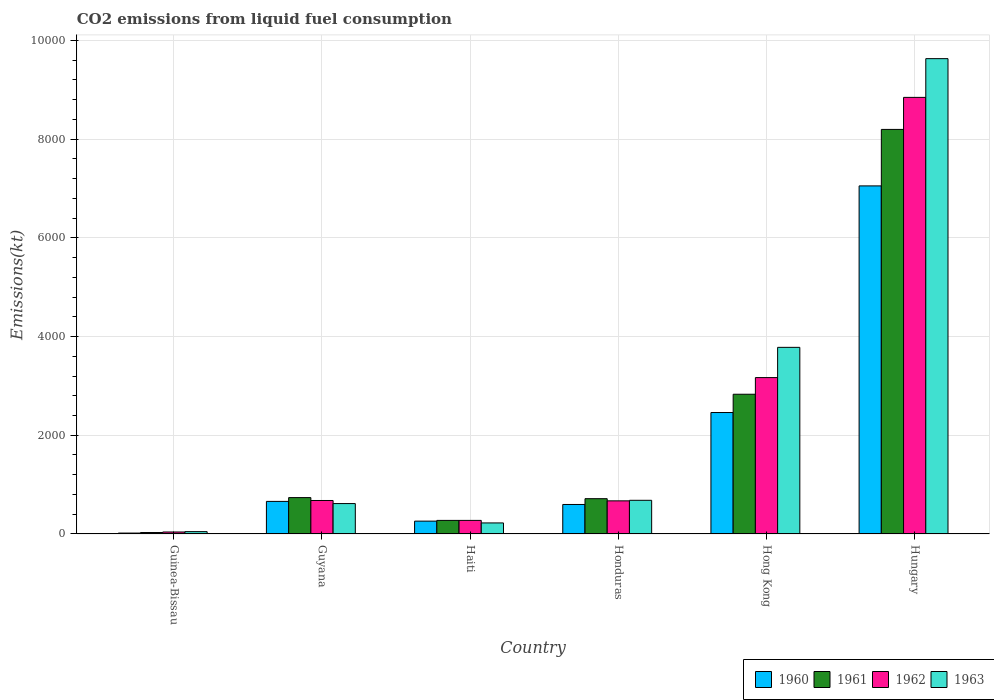How many different coloured bars are there?
Keep it short and to the point. 4. What is the label of the 5th group of bars from the left?
Give a very brief answer. Hong Kong. What is the amount of CO2 emitted in 1960 in Hungary?
Your answer should be very brief. 7051.64. Across all countries, what is the maximum amount of CO2 emitted in 1963?
Ensure brevity in your answer.  9629.54. Across all countries, what is the minimum amount of CO2 emitted in 1960?
Ensure brevity in your answer.  18.34. In which country was the amount of CO2 emitted in 1961 maximum?
Make the answer very short. Hungary. In which country was the amount of CO2 emitted in 1963 minimum?
Make the answer very short. Guinea-Bissau. What is the total amount of CO2 emitted in 1961 in the graph?
Your answer should be very brief. 1.28e+04. What is the difference between the amount of CO2 emitted in 1960 in Haiti and that in Hong Kong?
Ensure brevity in your answer.  -2200.2. What is the difference between the amount of CO2 emitted in 1962 in Haiti and the amount of CO2 emitted in 1963 in Guyana?
Your answer should be compact. -341.03. What is the average amount of CO2 emitted in 1962 per country?
Make the answer very short. 2279.65. What is the difference between the amount of CO2 emitted of/in 1963 and amount of CO2 emitted of/in 1962 in Guyana?
Your response must be concise. -62.34. What is the ratio of the amount of CO2 emitted in 1960 in Guyana to that in Honduras?
Your response must be concise. 1.1. Is the amount of CO2 emitted in 1961 in Guinea-Bissau less than that in Haiti?
Provide a short and direct response. Yes. Is the difference between the amount of CO2 emitted in 1963 in Guinea-Bissau and Hong Kong greater than the difference between the amount of CO2 emitted in 1962 in Guinea-Bissau and Hong Kong?
Make the answer very short. No. What is the difference between the highest and the second highest amount of CO2 emitted in 1962?
Your response must be concise. -5676.52. What is the difference between the highest and the lowest amount of CO2 emitted in 1961?
Keep it short and to the point. 8166.41. Is the sum of the amount of CO2 emitted in 1963 in Guyana and Hungary greater than the maximum amount of CO2 emitted in 1962 across all countries?
Give a very brief answer. Yes. What does the 4th bar from the left in Hungary represents?
Ensure brevity in your answer.  1963. What does the 3rd bar from the right in Guinea-Bissau represents?
Your answer should be very brief. 1961. Is it the case that in every country, the sum of the amount of CO2 emitted in 1963 and amount of CO2 emitted in 1962 is greater than the amount of CO2 emitted in 1960?
Offer a terse response. Yes. How many bars are there?
Make the answer very short. 24. Are all the bars in the graph horizontal?
Offer a very short reply. No. What is the difference between two consecutive major ticks on the Y-axis?
Provide a short and direct response. 2000. What is the title of the graph?
Provide a short and direct response. CO2 emissions from liquid fuel consumption. What is the label or title of the Y-axis?
Provide a succinct answer. Emissions(kt). What is the Emissions(kt) of 1960 in Guinea-Bissau?
Provide a short and direct response. 18.34. What is the Emissions(kt) in 1961 in Guinea-Bissau?
Ensure brevity in your answer.  29.34. What is the Emissions(kt) in 1962 in Guinea-Bissau?
Provide a succinct answer. 40.34. What is the Emissions(kt) of 1963 in Guinea-Bissau?
Offer a very short reply. 47.67. What is the Emissions(kt) in 1960 in Guyana?
Your response must be concise. 660.06. What is the Emissions(kt) in 1961 in Guyana?
Your answer should be very brief. 737.07. What is the Emissions(kt) in 1962 in Guyana?
Your answer should be very brief. 678.39. What is the Emissions(kt) of 1963 in Guyana?
Keep it short and to the point. 616.06. What is the Emissions(kt) in 1960 in Haiti?
Offer a very short reply. 260.36. What is the Emissions(kt) of 1961 in Haiti?
Your answer should be compact. 275.02. What is the Emissions(kt) of 1962 in Haiti?
Give a very brief answer. 275.02. What is the Emissions(kt) of 1963 in Haiti?
Your response must be concise. 223.69. What is the Emissions(kt) in 1960 in Honduras?
Make the answer very short. 597.72. What is the Emissions(kt) of 1961 in Honduras?
Ensure brevity in your answer.  715.07. What is the Emissions(kt) in 1962 in Honduras?
Give a very brief answer. 671.06. What is the Emissions(kt) of 1963 in Honduras?
Offer a very short reply. 682.06. What is the Emissions(kt) in 1960 in Hong Kong?
Provide a short and direct response. 2460.56. What is the Emissions(kt) in 1961 in Hong Kong?
Make the answer very short. 2830.92. What is the Emissions(kt) of 1962 in Hong Kong?
Make the answer very short. 3168.29. What is the Emissions(kt) of 1963 in Hong Kong?
Your response must be concise. 3780.68. What is the Emissions(kt) of 1960 in Hungary?
Your answer should be very brief. 7051.64. What is the Emissions(kt) of 1961 in Hungary?
Give a very brief answer. 8195.75. What is the Emissions(kt) in 1962 in Hungary?
Give a very brief answer. 8844.8. What is the Emissions(kt) of 1963 in Hungary?
Offer a very short reply. 9629.54. Across all countries, what is the maximum Emissions(kt) in 1960?
Your answer should be very brief. 7051.64. Across all countries, what is the maximum Emissions(kt) of 1961?
Provide a short and direct response. 8195.75. Across all countries, what is the maximum Emissions(kt) in 1962?
Provide a succinct answer. 8844.8. Across all countries, what is the maximum Emissions(kt) in 1963?
Make the answer very short. 9629.54. Across all countries, what is the minimum Emissions(kt) in 1960?
Your answer should be compact. 18.34. Across all countries, what is the minimum Emissions(kt) in 1961?
Your answer should be very brief. 29.34. Across all countries, what is the minimum Emissions(kt) in 1962?
Your answer should be very brief. 40.34. Across all countries, what is the minimum Emissions(kt) in 1963?
Your response must be concise. 47.67. What is the total Emissions(kt) of 1960 in the graph?
Ensure brevity in your answer.  1.10e+04. What is the total Emissions(kt) in 1961 in the graph?
Provide a succinct answer. 1.28e+04. What is the total Emissions(kt) in 1962 in the graph?
Offer a very short reply. 1.37e+04. What is the total Emissions(kt) of 1963 in the graph?
Keep it short and to the point. 1.50e+04. What is the difference between the Emissions(kt) of 1960 in Guinea-Bissau and that in Guyana?
Your answer should be compact. -641.73. What is the difference between the Emissions(kt) of 1961 in Guinea-Bissau and that in Guyana?
Your response must be concise. -707.73. What is the difference between the Emissions(kt) of 1962 in Guinea-Bissau and that in Guyana?
Keep it short and to the point. -638.06. What is the difference between the Emissions(kt) in 1963 in Guinea-Bissau and that in Guyana?
Your answer should be compact. -568.38. What is the difference between the Emissions(kt) of 1960 in Guinea-Bissau and that in Haiti?
Offer a very short reply. -242.02. What is the difference between the Emissions(kt) of 1961 in Guinea-Bissau and that in Haiti?
Offer a terse response. -245.69. What is the difference between the Emissions(kt) in 1962 in Guinea-Bissau and that in Haiti?
Your answer should be very brief. -234.69. What is the difference between the Emissions(kt) of 1963 in Guinea-Bissau and that in Haiti?
Provide a short and direct response. -176.02. What is the difference between the Emissions(kt) in 1960 in Guinea-Bissau and that in Honduras?
Make the answer very short. -579.39. What is the difference between the Emissions(kt) in 1961 in Guinea-Bissau and that in Honduras?
Offer a very short reply. -685.73. What is the difference between the Emissions(kt) in 1962 in Guinea-Bissau and that in Honduras?
Provide a short and direct response. -630.72. What is the difference between the Emissions(kt) of 1963 in Guinea-Bissau and that in Honduras?
Provide a succinct answer. -634.39. What is the difference between the Emissions(kt) in 1960 in Guinea-Bissau and that in Hong Kong?
Give a very brief answer. -2442.22. What is the difference between the Emissions(kt) of 1961 in Guinea-Bissau and that in Hong Kong?
Offer a very short reply. -2801.59. What is the difference between the Emissions(kt) of 1962 in Guinea-Bissau and that in Hong Kong?
Your answer should be very brief. -3127.95. What is the difference between the Emissions(kt) of 1963 in Guinea-Bissau and that in Hong Kong?
Give a very brief answer. -3733.01. What is the difference between the Emissions(kt) in 1960 in Guinea-Bissau and that in Hungary?
Ensure brevity in your answer.  -7033.31. What is the difference between the Emissions(kt) of 1961 in Guinea-Bissau and that in Hungary?
Offer a terse response. -8166.41. What is the difference between the Emissions(kt) of 1962 in Guinea-Bissau and that in Hungary?
Keep it short and to the point. -8804.47. What is the difference between the Emissions(kt) in 1963 in Guinea-Bissau and that in Hungary?
Ensure brevity in your answer.  -9581.87. What is the difference between the Emissions(kt) of 1960 in Guyana and that in Haiti?
Make the answer very short. 399.7. What is the difference between the Emissions(kt) of 1961 in Guyana and that in Haiti?
Ensure brevity in your answer.  462.04. What is the difference between the Emissions(kt) of 1962 in Guyana and that in Haiti?
Offer a terse response. 403.37. What is the difference between the Emissions(kt) of 1963 in Guyana and that in Haiti?
Your answer should be very brief. 392.37. What is the difference between the Emissions(kt) in 1960 in Guyana and that in Honduras?
Your response must be concise. 62.34. What is the difference between the Emissions(kt) in 1961 in Guyana and that in Honduras?
Your answer should be very brief. 22. What is the difference between the Emissions(kt) of 1962 in Guyana and that in Honduras?
Your response must be concise. 7.33. What is the difference between the Emissions(kt) in 1963 in Guyana and that in Honduras?
Ensure brevity in your answer.  -66.01. What is the difference between the Emissions(kt) of 1960 in Guyana and that in Hong Kong?
Offer a very short reply. -1800.5. What is the difference between the Emissions(kt) of 1961 in Guyana and that in Hong Kong?
Your answer should be compact. -2093.86. What is the difference between the Emissions(kt) of 1962 in Guyana and that in Hong Kong?
Provide a short and direct response. -2489.89. What is the difference between the Emissions(kt) of 1963 in Guyana and that in Hong Kong?
Offer a very short reply. -3164.62. What is the difference between the Emissions(kt) of 1960 in Guyana and that in Hungary?
Provide a succinct answer. -6391.58. What is the difference between the Emissions(kt) of 1961 in Guyana and that in Hungary?
Offer a very short reply. -7458.68. What is the difference between the Emissions(kt) in 1962 in Guyana and that in Hungary?
Make the answer very short. -8166.41. What is the difference between the Emissions(kt) in 1963 in Guyana and that in Hungary?
Your answer should be compact. -9013.49. What is the difference between the Emissions(kt) in 1960 in Haiti and that in Honduras?
Ensure brevity in your answer.  -337.36. What is the difference between the Emissions(kt) in 1961 in Haiti and that in Honduras?
Give a very brief answer. -440.04. What is the difference between the Emissions(kt) in 1962 in Haiti and that in Honduras?
Offer a very short reply. -396.04. What is the difference between the Emissions(kt) in 1963 in Haiti and that in Honduras?
Keep it short and to the point. -458.38. What is the difference between the Emissions(kt) of 1960 in Haiti and that in Hong Kong?
Provide a short and direct response. -2200.2. What is the difference between the Emissions(kt) of 1961 in Haiti and that in Hong Kong?
Offer a very short reply. -2555.9. What is the difference between the Emissions(kt) of 1962 in Haiti and that in Hong Kong?
Your response must be concise. -2893.26. What is the difference between the Emissions(kt) in 1963 in Haiti and that in Hong Kong?
Keep it short and to the point. -3556.99. What is the difference between the Emissions(kt) in 1960 in Haiti and that in Hungary?
Provide a short and direct response. -6791.28. What is the difference between the Emissions(kt) of 1961 in Haiti and that in Hungary?
Provide a succinct answer. -7920.72. What is the difference between the Emissions(kt) in 1962 in Haiti and that in Hungary?
Provide a short and direct response. -8569.78. What is the difference between the Emissions(kt) in 1963 in Haiti and that in Hungary?
Ensure brevity in your answer.  -9405.85. What is the difference between the Emissions(kt) of 1960 in Honduras and that in Hong Kong?
Keep it short and to the point. -1862.84. What is the difference between the Emissions(kt) of 1961 in Honduras and that in Hong Kong?
Offer a very short reply. -2115.86. What is the difference between the Emissions(kt) of 1962 in Honduras and that in Hong Kong?
Give a very brief answer. -2497.23. What is the difference between the Emissions(kt) in 1963 in Honduras and that in Hong Kong?
Your answer should be very brief. -3098.61. What is the difference between the Emissions(kt) of 1960 in Honduras and that in Hungary?
Provide a short and direct response. -6453.92. What is the difference between the Emissions(kt) of 1961 in Honduras and that in Hungary?
Ensure brevity in your answer.  -7480.68. What is the difference between the Emissions(kt) of 1962 in Honduras and that in Hungary?
Keep it short and to the point. -8173.74. What is the difference between the Emissions(kt) of 1963 in Honduras and that in Hungary?
Keep it short and to the point. -8947.48. What is the difference between the Emissions(kt) in 1960 in Hong Kong and that in Hungary?
Offer a very short reply. -4591.08. What is the difference between the Emissions(kt) in 1961 in Hong Kong and that in Hungary?
Make the answer very short. -5364.82. What is the difference between the Emissions(kt) of 1962 in Hong Kong and that in Hungary?
Provide a succinct answer. -5676.52. What is the difference between the Emissions(kt) of 1963 in Hong Kong and that in Hungary?
Your answer should be very brief. -5848.86. What is the difference between the Emissions(kt) of 1960 in Guinea-Bissau and the Emissions(kt) of 1961 in Guyana?
Keep it short and to the point. -718.73. What is the difference between the Emissions(kt) in 1960 in Guinea-Bissau and the Emissions(kt) in 1962 in Guyana?
Ensure brevity in your answer.  -660.06. What is the difference between the Emissions(kt) of 1960 in Guinea-Bissau and the Emissions(kt) of 1963 in Guyana?
Your answer should be very brief. -597.72. What is the difference between the Emissions(kt) in 1961 in Guinea-Bissau and the Emissions(kt) in 1962 in Guyana?
Keep it short and to the point. -649.06. What is the difference between the Emissions(kt) of 1961 in Guinea-Bissau and the Emissions(kt) of 1963 in Guyana?
Your answer should be compact. -586.72. What is the difference between the Emissions(kt) of 1962 in Guinea-Bissau and the Emissions(kt) of 1963 in Guyana?
Your answer should be very brief. -575.72. What is the difference between the Emissions(kt) of 1960 in Guinea-Bissau and the Emissions(kt) of 1961 in Haiti?
Ensure brevity in your answer.  -256.69. What is the difference between the Emissions(kt) of 1960 in Guinea-Bissau and the Emissions(kt) of 1962 in Haiti?
Ensure brevity in your answer.  -256.69. What is the difference between the Emissions(kt) in 1960 in Guinea-Bissau and the Emissions(kt) in 1963 in Haiti?
Your response must be concise. -205.35. What is the difference between the Emissions(kt) of 1961 in Guinea-Bissau and the Emissions(kt) of 1962 in Haiti?
Ensure brevity in your answer.  -245.69. What is the difference between the Emissions(kt) in 1961 in Guinea-Bissau and the Emissions(kt) in 1963 in Haiti?
Offer a terse response. -194.35. What is the difference between the Emissions(kt) in 1962 in Guinea-Bissau and the Emissions(kt) in 1963 in Haiti?
Provide a short and direct response. -183.35. What is the difference between the Emissions(kt) of 1960 in Guinea-Bissau and the Emissions(kt) of 1961 in Honduras?
Offer a very short reply. -696.73. What is the difference between the Emissions(kt) in 1960 in Guinea-Bissau and the Emissions(kt) in 1962 in Honduras?
Provide a succinct answer. -652.73. What is the difference between the Emissions(kt) in 1960 in Guinea-Bissau and the Emissions(kt) in 1963 in Honduras?
Make the answer very short. -663.73. What is the difference between the Emissions(kt) of 1961 in Guinea-Bissau and the Emissions(kt) of 1962 in Honduras?
Offer a very short reply. -641.73. What is the difference between the Emissions(kt) in 1961 in Guinea-Bissau and the Emissions(kt) in 1963 in Honduras?
Provide a succinct answer. -652.73. What is the difference between the Emissions(kt) in 1962 in Guinea-Bissau and the Emissions(kt) in 1963 in Honduras?
Offer a very short reply. -641.73. What is the difference between the Emissions(kt) in 1960 in Guinea-Bissau and the Emissions(kt) in 1961 in Hong Kong?
Offer a very short reply. -2812.59. What is the difference between the Emissions(kt) in 1960 in Guinea-Bissau and the Emissions(kt) in 1962 in Hong Kong?
Your answer should be very brief. -3149.95. What is the difference between the Emissions(kt) of 1960 in Guinea-Bissau and the Emissions(kt) of 1963 in Hong Kong?
Offer a very short reply. -3762.34. What is the difference between the Emissions(kt) of 1961 in Guinea-Bissau and the Emissions(kt) of 1962 in Hong Kong?
Give a very brief answer. -3138.95. What is the difference between the Emissions(kt) of 1961 in Guinea-Bissau and the Emissions(kt) of 1963 in Hong Kong?
Provide a short and direct response. -3751.34. What is the difference between the Emissions(kt) in 1962 in Guinea-Bissau and the Emissions(kt) in 1963 in Hong Kong?
Your answer should be very brief. -3740.34. What is the difference between the Emissions(kt) of 1960 in Guinea-Bissau and the Emissions(kt) of 1961 in Hungary?
Make the answer very short. -8177.41. What is the difference between the Emissions(kt) of 1960 in Guinea-Bissau and the Emissions(kt) of 1962 in Hungary?
Your answer should be very brief. -8826.47. What is the difference between the Emissions(kt) of 1960 in Guinea-Bissau and the Emissions(kt) of 1963 in Hungary?
Provide a succinct answer. -9611.21. What is the difference between the Emissions(kt) in 1961 in Guinea-Bissau and the Emissions(kt) in 1962 in Hungary?
Provide a short and direct response. -8815.47. What is the difference between the Emissions(kt) of 1961 in Guinea-Bissau and the Emissions(kt) of 1963 in Hungary?
Provide a succinct answer. -9600.21. What is the difference between the Emissions(kt) in 1962 in Guinea-Bissau and the Emissions(kt) in 1963 in Hungary?
Ensure brevity in your answer.  -9589.2. What is the difference between the Emissions(kt) in 1960 in Guyana and the Emissions(kt) in 1961 in Haiti?
Provide a succinct answer. 385.04. What is the difference between the Emissions(kt) in 1960 in Guyana and the Emissions(kt) in 1962 in Haiti?
Offer a terse response. 385.04. What is the difference between the Emissions(kt) of 1960 in Guyana and the Emissions(kt) of 1963 in Haiti?
Your answer should be compact. 436.37. What is the difference between the Emissions(kt) in 1961 in Guyana and the Emissions(kt) in 1962 in Haiti?
Your answer should be compact. 462.04. What is the difference between the Emissions(kt) in 1961 in Guyana and the Emissions(kt) in 1963 in Haiti?
Ensure brevity in your answer.  513.38. What is the difference between the Emissions(kt) of 1962 in Guyana and the Emissions(kt) of 1963 in Haiti?
Keep it short and to the point. 454.71. What is the difference between the Emissions(kt) of 1960 in Guyana and the Emissions(kt) of 1961 in Honduras?
Keep it short and to the point. -55.01. What is the difference between the Emissions(kt) of 1960 in Guyana and the Emissions(kt) of 1962 in Honduras?
Offer a very short reply. -11. What is the difference between the Emissions(kt) of 1960 in Guyana and the Emissions(kt) of 1963 in Honduras?
Give a very brief answer. -22. What is the difference between the Emissions(kt) of 1961 in Guyana and the Emissions(kt) of 1962 in Honduras?
Provide a succinct answer. 66.01. What is the difference between the Emissions(kt) of 1961 in Guyana and the Emissions(kt) of 1963 in Honduras?
Make the answer very short. 55.01. What is the difference between the Emissions(kt) in 1962 in Guyana and the Emissions(kt) in 1963 in Honduras?
Your answer should be very brief. -3.67. What is the difference between the Emissions(kt) of 1960 in Guyana and the Emissions(kt) of 1961 in Hong Kong?
Your response must be concise. -2170.86. What is the difference between the Emissions(kt) of 1960 in Guyana and the Emissions(kt) of 1962 in Hong Kong?
Your answer should be compact. -2508.23. What is the difference between the Emissions(kt) in 1960 in Guyana and the Emissions(kt) in 1963 in Hong Kong?
Provide a short and direct response. -3120.62. What is the difference between the Emissions(kt) of 1961 in Guyana and the Emissions(kt) of 1962 in Hong Kong?
Your response must be concise. -2431.22. What is the difference between the Emissions(kt) of 1961 in Guyana and the Emissions(kt) of 1963 in Hong Kong?
Provide a short and direct response. -3043.61. What is the difference between the Emissions(kt) of 1962 in Guyana and the Emissions(kt) of 1963 in Hong Kong?
Keep it short and to the point. -3102.28. What is the difference between the Emissions(kt) of 1960 in Guyana and the Emissions(kt) of 1961 in Hungary?
Provide a short and direct response. -7535.69. What is the difference between the Emissions(kt) of 1960 in Guyana and the Emissions(kt) of 1962 in Hungary?
Your answer should be very brief. -8184.74. What is the difference between the Emissions(kt) in 1960 in Guyana and the Emissions(kt) in 1963 in Hungary?
Your answer should be compact. -8969.48. What is the difference between the Emissions(kt) of 1961 in Guyana and the Emissions(kt) of 1962 in Hungary?
Ensure brevity in your answer.  -8107.74. What is the difference between the Emissions(kt) in 1961 in Guyana and the Emissions(kt) in 1963 in Hungary?
Provide a succinct answer. -8892.48. What is the difference between the Emissions(kt) in 1962 in Guyana and the Emissions(kt) in 1963 in Hungary?
Your answer should be very brief. -8951.15. What is the difference between the Emissions(kt) in 1960 in Haiti and the Emissions(kt) in 1961 in Honduras?
Offer a very short reply. -454.71. What is the difference between the Emissions(kt) of 1960 in Haiti and the Emissions(kt) of 1962 in Honduras?
Give a very brief answer. -410.7. What is the difference between the Emissions(kt) in 1960 in Haiti and the Emissions(kt) in 1963 in Honduras?
Your answer should be very brief. -421.7. What is the difference between the Emissions(kt) in 1961 in Haiti and the Emissions(kt) in 1962 in Honduras?
Give a very brief answer. -396.04. What is the difference between the Emissions(kt) in 1961 in Haiti and the Emissions(kt) in 1963 in Honduras?
Your answer should be very brief. -407.04. What is the difference between the Emissions(kt) of 1962 in Haiti and the Emissions(kt) of 1963 in Honduras?
Ensure brevity in your answer.  -407.04. What is the difference between the Emissions(kt) of 1960 in Haiti and the Emissions(kt) of 1961 in Hong Kong?
Offer a very short reply. -2570.57. What is the difference between the Emissions(kt) in 1960 in Haiti and the Emissions(kt) in 1962 in Hong Kong?
Offer a very short reply. -2907.93. What is the difference between the Emissions(kt) in 1960 in Haiti and the Emissions(kt) in 1963 in Hong Kong?
Give a very brief answer. -3520.32. What is the difference between the Emissions(kt) of 1961 in Haiti and the Emissions(kt) of 1962 in Hong Kong?
Provide a short and direct response. -2893.26. What is the difference between the Emissions(kt) of 1961 in Haiti and the Emissions(kt) of 1963 in Hong Kong?
Keep it short and to the point. -3505.65. What is the difference between the Emissions(kt) of 1962 in Haiti and the Emissions(kt) of 1963 in Hong Kong?
Offer a terse response. -3505.65. What is the difference between the Emissions(kt) in 1960 in Haiti and the Emissions(kt) in 1961 in Hungary?
Provide a short and direct response. -7935.39. What is the difference between the Emissions(kt) in 1960 in Haiti and the Emissions(kt) in 1962 in Hungary?
Provide a short and direct response. -8584.45. What is the difference between the Emissions(kt) of 1960 in Haiti and the Emissions(kt) of 1963 in Hungary?
Provide a succinct answer. -9369.18. What is the difference between the Emissions(kt) in 1961 in Haiti and the Emissions(kt) in 1962 in Hungary?
Give a very brief answer. -8569.78. What is the difference between the Emissions(kt) of 1961 in Haiti and the Emissions(kt) of 1963 in Hungary?
Offer a terse response. -9354.52. What is the difference between the Emissions(kt) of 1962 in Haiti and the Emissions(kt) of 1963 in Hungary?
Your answer should be compact. -9354.52. What is the difference between the Emissions(kt) of 1960 in Honduras and the Emissions(kt) of 1961 in Hong Kong?
Give a very brief answer. -2233.2. What is the difference between the Emissions(kt) in 1960 in Honduras and the Emissions(kt) in 1962 in Hong Kong?
Keep it short and to the point. -2570.57. What is the difference between the Emissions(kt) in 1960 in Honduras and the Emissions(kt) in 1963 in Hong Kong?
Keep it short and to the point. -3182.96. What is the difference between the Emissions(kt) of 1961 in Honduras and the Emissions(kt) of 1962 in Hong Kong?
Ensure brevity in your answer.  -2453.22. What is the difference between the Emissions(kt) of 1961 in Honduras and the Emissions(kt) of 1963 in Hong Kong?
Your answer should be compact. -3065.61. What is the difference between the Emissions(kt) in 1962 in Honduras and the Emissions(kt) in 1963 in Hong Kong?
Ensure brevity in your answer.  -3109.62. What is the difference between the Emissions(kt) in 1960 in Honduras and the Emissions(kt) in 1961 in Hungary?
Ensure brevity in your answer.  -7598.02. What is the difference between the Emissions(kt) of 1960 in Honduras and the Emissions(kt) of 1962 in Hungary?
Give a very brief answer. -8247.08. What is the difference between the Emissions(kt) of 1960 in Honduras and the Emissions(kt) of 1963 in Hungary?
Give a very brief answer. -9031.82. What is the difference between the Emissions(kt) of 1961 in Honduras and the Emissions(kt) of 1962 in Hungary?
Make the answer very short. -8129.74. What is the difference between the Emissions(kt) in 1961 in Honduras and the Emissions(kt) in 1963 in Hungary?
Offer a very short reply. -8914.48. What is the difference between the Emissions(kt) in 1962 in Honduras and the Emissions(kt) in 1963 in Hungary?
Offer a very short reply. -8958.48. What is the difference between the Emissions(kt) in 1960 in Hong Kong and the Emissions(kt) in 1961 in Hungary?
Ensure brevity in your answer.  -5735.19. What is the difference between the Emissions(kt) of 1960 in Hong Kong and the Emissions(kt) of 1962 in Hungary?
Offer a very short reply. -6384.25. What is the difference between the Emissions(kt) in 1960 in Hong Kong and the Emissions(kt) in 1963 in Hungary?
Provide a short and direct response. -7168.98. What is the difference between the Emissions(kt) in 1961 in Hong Kong and the Emissions(kt) in 1962 in Hungary?
Provide a succinct answer. -6013.88. What is the difference between the Emissions(kt) in 1961 in Hong Kong and the Emissions(kt) in 1963 in Hungary?
Provide a short and direct response. -6798.62. What is the difference between the Emissions(kt) of 1962 in Hong Kong and the Emissions(kt) of 1963 in Hungary?
Offer a very short reply. -6461.25. What is the average Emissions(kt) in 1960 per country?
Your answer should be very brief. 1841.45. What is the average Emissions(kt) in 1961 per country?
Keep it short and to the point. 2130.53. What is the average Emissions(kt) in 1962 per country?
Your response must be concise. 2279.65. What is the average Emissions(kt) of 1963 per country?
Offer a very short reply. 2496.62. What is the difference between the Emissions(kt) in 1960 and Emissions(kt) in 1961 in Guinea-Bissau?
Your answer should be very brief. -11. What is the difference between the Emissions(kt) in 1960 and Emissions(kt) in 1962 in Guinea-Bissau?
Ensure brevity in your answer.  -22. What is the difference between the Emissions(kt) of 1960 and Emissions(kt) of 1963 in Guinea-Bissau?
Your response must be concise. -29.34. What is the difference between the Emissions(kt) of 1961 and Emissions(kt) of 1962 in Guinea-Bissau?
Make the answer very short. -11. What is the difference between the Emissions(kt) of 1961 and Emissions(kt) of 1963 in Guinea-Bissau?
Your answer should be compact. -18.34. What is the difference between the Emissions(kt) of 1962 and Emissions(kt) of 1963 in Guinea-Bissau?
Provide a short and direct response. -7.33. What is the difference between the Emissions(kt) of 1960 and Emissions(kt) of 1961 in Guyana?
Give a very brief answer. -77.01. What is the difference between the Emissions(kt) of 1960 and Emissions(kt) of 1962 in Guyana?
Your response must be concise. -18.34. What is the difference between the Emissions(kt) in 1960 and Emissions(kt) in 1963 in Guyana?
Ensure brevity in your answer.  44. What is the difference between the Emissions(kt) in 1961 and Emissions(kt) in 1962 in Guyana?
Your answer should be compact. 58.67. What is the difference between the Emissions(kt) in 1961 and Emissions(kt) in 1963 in Guyana?
Provide a short and direct response. 121.01. What is the difference between the Emissions(kt) of 1962 and Emissions(kt) of 1963 in Guyana?
Your answer should be very brief. 62.34. What is the difference between the Emissions(kt) in 1960 and Emissions(kt) in 1961 in Haiti?
Ensure brevity in your answer.  -14.67. What is the difference between the Emissions(kt) in 1960 and Emissions(kt) in 1962 in Haiti?
Your answer should be compact. -14.67. What is the difference between the Emissions(kt) in 1960 and Emissions(kt) in 1963 in Haiti?
Provide a short and direct response. 36.67. What is the difference between the Emissions(kt) of 1961 and Emissions(kt) of 1962 in Haiti?
Keep it short and to the point. 0. What is the difference between the Emissions(kt) of 1961 and Emissions(kt) of 1963 in Haiti?
Ensure brevity in your answer.  51.34. What is the difference between the Emissions(kt) of 1962 and Emissions(kt) of 1963 in Haiti?
Your answer should be compact. 51.34. What is the difference between the Emissions(kt) in 1960 and Emissions(kt) in 1961 in Honduras?
Give a very brief answer. -117.34. What is the difference between the Emissions(kt) of 1960 and Emissions(kt) of 1962 in Honduras?
Give a very brief answer. -73.34. What is the difference between the Emissions(kt) of 1960 and Emissions(kt) of 1963 in Honduras?
Your response must be concise. -84.34. What is the difference between the Emissions(kt) of 1961 and Emissions(kt) of 1962 in Honduras?
Provide a succinct answer. 44. What is the difference between the Emissions(kt) in 1961 and Emissions(kt) in 1963 in Honduras?
Ensure brevity in your answer.  33. What is the difference between the Emissions(kt) in 1962 and Emissions(kt) in 1963 in Honduras?
Ensure brevity in your answer.  -11. What is the difference between the Emissions(kt) of 1960 and Emissions(kt) of 1961 in Hong Kong?
Your answer should be compact. -370.37. What is the difference between the Emissions(kt) in 1960 and Emissions(kt) in 1962 in Hong Kong?
Offer a terse response. -707.73. What is the difference between the Emissions(kt) in 1960 and Emissions(kt) in 1963 in Hong Kong?
Ensure brevity in your answer.  -1320.12. What is the difference between the Emissions(kt) of 1961 and Emissions(kt) of 1962 in Hong Kong?
Your answer should be compact. -337.36. What is the difference between the Emissions(kt) in 1961 and Emissions(kt) in 1963 in Hong Kong?
Offer a very short reply. -949.75. What is the difference between the Emissions(kt) of 1962 and Emissions(kt) of 1963 in Hong Kong?
Provide a short and direct response. -612.39. What is the difference between the Emissions(kt) in 1960 and Emissions(kt) in 1961 in Hungary?
Provide a succinct answer. -1144.1. What is the difference between the Emissions(kt) of 1960 and Emissions(kt) of 1962 in Hungary?
Offer a terse response. -1793.16. What is the difference between the Emissions(kt) in 1960 and Emissions(kt) in 1963 in Hungary?
Provide a short and direct response. -2577.9. What is the difference between the Emissions(kt) of 1961 and Emissions(kt) of 1962 in Hungary?
Your answer should be compact. -649.06. What is the difference between the Emissions(kt) of 1961 and Emissions(kt) of 1963 in Hungary?
Your answer should be compact. -1433.8. What is the difference between the Emissions(kt) of 1962 and Emissions(kt) of 1963 in Hungary?
Your answer should be compact. -784.74. What is the ratio of the Emissions(kt) in 1960 in Guinea-Bissau to that in Guyana?
Give a very brief answer. 0.03. What is the ratio of the Emissions(kt) in 1961 in Guinea-Bissau to that in Guyana?
Your response must be concise. 0.04. What is the ratio of the Emissions(kt) in 1962 in Guinea-Bissau to that in Guyana?
Offer a very short reply. 0.06. What is the ratio of the Emissions(kt) in 1963 in Guinea-Bissau to that in Guyana?
Offer a terse response. 0.08. What is the ratio of the Emissions(kt) in 1960 in Guinea-Bissau to that in Haiti?
Your answer should be very brief. 0.07. What is the ratio of the Emissions(kt) of 1961 in Guinea-Bissau to that in Haiti?
Your response must be concise. 0.11. What is the ratio of the Emissions(kt) in 1962 in Guinea-Bissau to that in Haiti?
Keep it short and to the point. 0.15. What is the ratio of the Emissions(kt) in 1963 in Guinea-Bissau to that in Haiti?
Offer a very short reply. 0.21. What is the ratio of the Emissions(kt) of 1960 in Guinea-Bissau to that in Honduras?
Make the answer very short. 0.03. What is the ratio of the Emissions(kt) in 1961 in Guinea-Bissau to that in Honduras?
Your answer should be very brief. 0.04. What is the ratio of the Emissions(kt) in 1962 in Guinea-Bissau to that in Honduras?
Your answer should be very brief. 0.06. What is the ratio of the Emissions(kt) of 1963 in Guinea-Bissau to that in Honduras?
Offer a terse response. 0.07. What is the ratio of the Emissions(kt) in 1960 in Guinea-Bissau to that in Hong Kong?
Make the answer very short. 0.01. What is the ratio of the Emissions(kt) of 1961 in Guinea-Bissau to that in Hong Kong?
Your response must be concise. 0.01. What is the ratio of the Emissions(kt) of 1962 in Guinea-Bissau to that in Hong Kong?
Provide a succinct answer. 0.01. What is the ratio of the Emissions(kt) of 1963 in Guinea-Bissau to that in Hong Kong?
Your answer should be very brief. 0.01. What is the ratio of the Emissions(kt) of 1960 in Guinea-Bissau to that in Hungary?
Make the answer very short. 0. What is the ratio of the Emissions(kt) in 1961 in Guinea-Bissau to that in Hungary?
Provide a succinct answer. 0. What is the ratio of the Emissions(kt) in 1962 in Guinea-Bissau to that in Hungary?
Your answer should be compact. 0. What is the ratio of the Emissions(kt) of 1963 in Guinea-Bissau to that in Hungary?
Offer a very short reply. 0.01. What is the ratio of the Emissions(kt) of 1960 in Guyana to that in Haiti?
Offer a very short reply. 2.54. What is the ratio of the Emissions(kt) of 1961 in Guyana to that in Haiti?
Ensure brevity in your answer.  2.68. What is the ratio of the Emissions(kt) of 1962 in Guyana to that in Haiti?
Provide a short and direct response. 2.47. What is the ratio of the Emissions(kt) of 1963 in Guyana to that in Haiti?
Give a very brief answer. 2.75. What is the ratio of the Emissions(kt) of 1960 in Guyana to that in Honduras?
Make the answer very short. 1.1. What is the ratio of the Emissions(kt) in 1961 in Guyana to that in Honduras?
Keep it short and to the point. 1.03. What is the ratio of the Emissions(kt) in 1962 in Guyana to that in Honduras?
Provide a short and direct response. 1.01. What is the ratio of the Emissions(kt) in 1963 in Guyana to that in Honduras?
Keep it short and to the point. 0.9. What is the ratio of the Emissions(kt) in 1960 in Guyana to that in Hong Kong?
Your response must be concise. 0.27. What is the ratio of the Emissions(kt) in 1961 in Guyana to that in Hong Kong?
Ensure brevity in your answer.  0.26. What is the ratio of the Emissions(kt) in 1962 in Guyana to that in Hong Kong?
Provide a succinct answer. 0.21. What is the ratio of the Emissions(kt) of 1963 in Guyana to that in Hong Kong?
Make the answer very short. 0.16. What is the ratio of the Emissions(kt) of 1960 in Guyana to that in Hungary?
Your answer should be very brief. 0.09. What is the ratio of the Emissions(kt) in 1961 in Guyana to that in Hungary?
Your answer should be compact. 0.09. What is the ratio of the Emissions(kt) in 1962 in Guyana to that in Hungary?
Keep it short and to the point. 0.08. What is the ratio of the Emissions(kt) of 1963 in Guyana to that in Hungary?
Provide a succinct answer. 0.06. What is the ratio of the Emissions(kt) in 1960 in Haiti to that in Honduras?
Offer a terse response. 0.44. What is the ratio of the Emissions(kt) in 1961 in Haiti to that in Honduras?
Ensure brevity in your answer.  0.38. What is the ratio of the Emissions(kt) in 1962 in Haiti to that in Honduras?
Ensure brevity in your answer.  0.41. What is the ratio of the Emissions(kt) in 1963 in Haiti to that in Honduras?
Keep it short and to the point. 0.33. What is the ratio of the Emissions(kt) in 1960 in Haiti to that in Hong Kong?
Your response must be concise. 0.11. What is the ratio of the Emissions(kt) in 1961 in Haiti to that in Hong Kong?
Your answer should be very brief. 0.1. What is the ratio of the Emissions(kt) in 1962 in Haiti to that in Hong Kong?
Provide a short and direct response. 0.09. What is the ratio of the Emissions(kt) in 1963 in Haiti to that in Hong Kong?
Give a very brief answer. 0.06. What is the ratio of the Emissions(kt) in 1960 in Haiti to that in Hungary?
Make the answer very short. 0.04. What is the ratio of the Emissions(kt) in 1961 in Haiti to that in Hungary?
Provide a succinct answer. 0.03. What is the ratio of the Emissions(kt) of 1962 in Haiti to that in Hungary?
Make the answer very short. 0.03. What is the ratio of the Emissions(kt) in 1963 in Haiti to that in Hungary?
Your answer should be compact. 0.02. What is the ratio of the Emissions(kt) in 1960 in Honduras to that in Hong Kong?
Your answer should be very brief. 0.24. What is the ratio of the Emissions(kt) in 1961 in Honduras to that in Hong Kong?
Your answer should be compact. 0.25. What is the ratio of the Emissions(kt) in 1962 in Honduras to that in Hong Kong?
Offer a very short reply. 0.21. What is the ratio of the Emissions(kt) of 1963 in Honduras to that in Hong Kong?
Ensure brevity in your answer.  0.18. What is the ratio of the Emissions(kt) in 1960 in Honduras to that in Hungary?
Your answer should be very brief. 0.08. What is the ratio of the Emissions(kt) in 1961 in Honduras to that in Hungary?
Offer a very short reply. 0.09. What is the ratio of the Emissions(kt) in 1962 in Honduras to that in Hungary?
Ensure brevity in your answer.  0.08. What is the ratio of the Emissions(kt) in 1963 in Honduras to that in Hungary?
Provide a short and direct response. 0.07. What is the ratio of the Emissions(kt) in 1960 in Hong Kong to that in Hungary?
Your answer should be very brief. 0.35. What is the ratio of the Emissions(kt) of 1961 in Hong Kong to that in Hungary?
Offer a very short reply. 0.35. What is the ratio of the Emissions(kt) in 1962 in Hong Kong to that in Hungary?
Make the answer very short. 0.36. What is the ratio of the Emissions(kt) of 1963 in Hong Kong to that in Hungary?
Your answer should be very brief. 0.39. What is the difference between the highest and the second highest Emissions(kt) of 1960?
Keep it short and to the point. 4591.08. What is the difference between the highest and the second highest Emissions(kt) of 1961?
Give a very brief answer. 5364.82. What is the difference between the highest and the second highest Emissions(kt) of 1962?
Ensure brevity in your answer.  5676.52. What is the difference between the highest and the second highest Emissions(kt) in 1963?
Keep it short and to the point. 5848.86. What is the difference between the highest and the lowest Emissions(kt) of 1960?
Your answer should be compact. 7033.31. What is the difference between the highest and the lowest Emissions(kt) of 1961?
Make the answer very short. 8166.41. What is the difference between the highest and the lowest Emissions(kt) in 1962?
Provide a short and direct response. 8804.47. What is the difference between the highest and the lowest Emissions(kt) of 1963?
Your answer should be compact. 9581.87. 